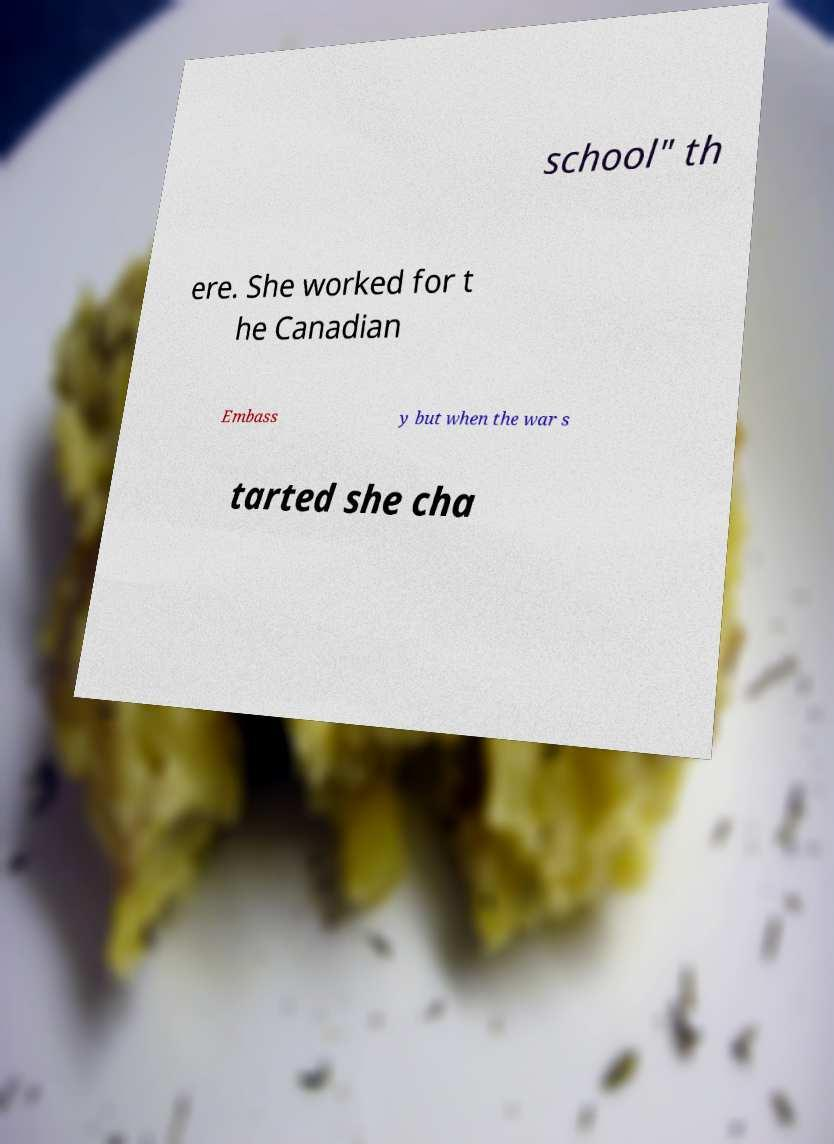There's text embedded in this image that I need extracted. Can you transcribe it verbatim? school" th ere. She worked for t he Canadian Embass y but when the war s tarted she cha 